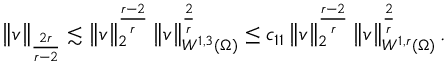<formula> <loc_0><loc_0><loc_500><loc_500>\left \| v \right \| _ { \frac { 2 r } { r - 2 } } \lesssim \left \| v \right \| _ { 2 } ^ { \frac { r - 2 } { r } } \left \| v \right \| _ { W ^ { 1 , 3 } ( \Omega ) } ^ { \frac { 2 } { r } } \leq c _ { 1 1 } \left \| v \right \| _ { 2 } ^ { \frac { r - 2 } { r } } \left \| v \right \| _ { W ^ { 1 , r } ( \Omega ) } ^ { \frac { 2 } { r } } .</formula> 